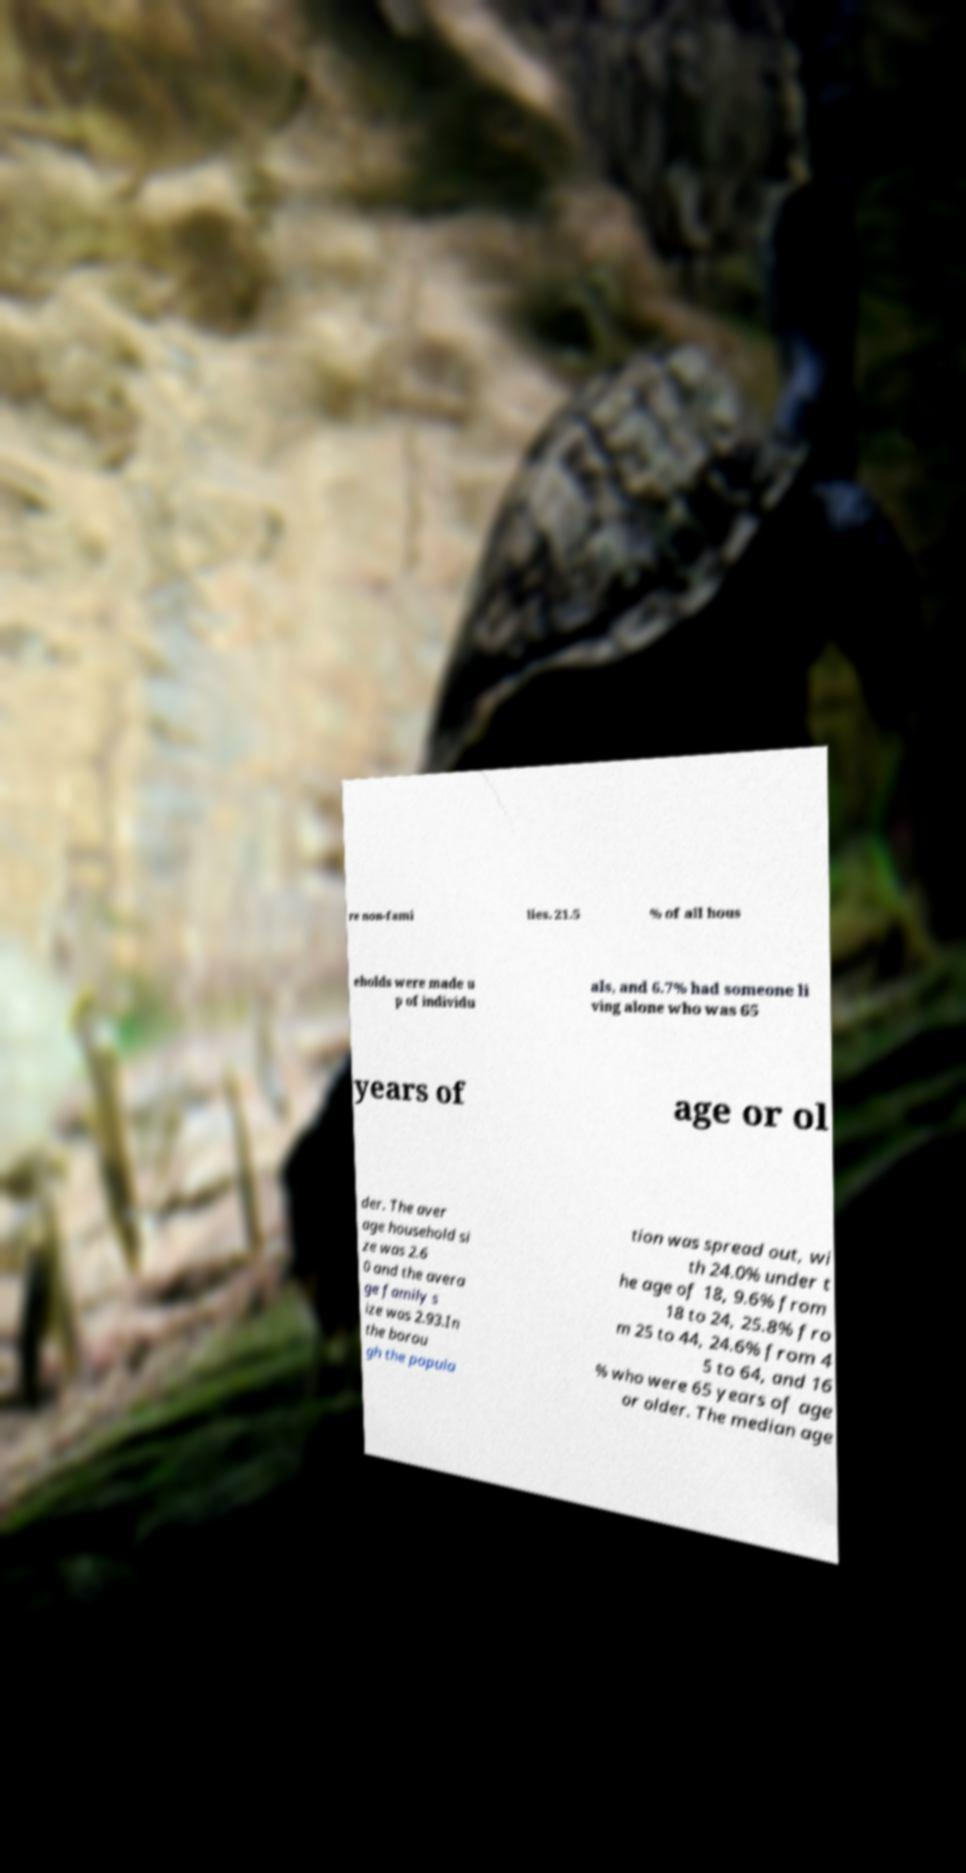For documentation purposes, I need the text within this image transcribed. Could you provide that? re non-fami lies. 21.5 % of all hous eholds were made u p of individu als, and 6.7% had someone li ving alone who was 65 years of age or ol der. The aver age household si ze was 2.6 0 and the avera ge family s ize was 2.93.In the borou gh the popula tion was spread out, wi th 24.0% under t he age of 18, 9.6% from 18 to 24, 25.8% fro m 25 to 44, 24.6% from 4 5 to 64, and 16 % who were 65 years of age or older. The median age 